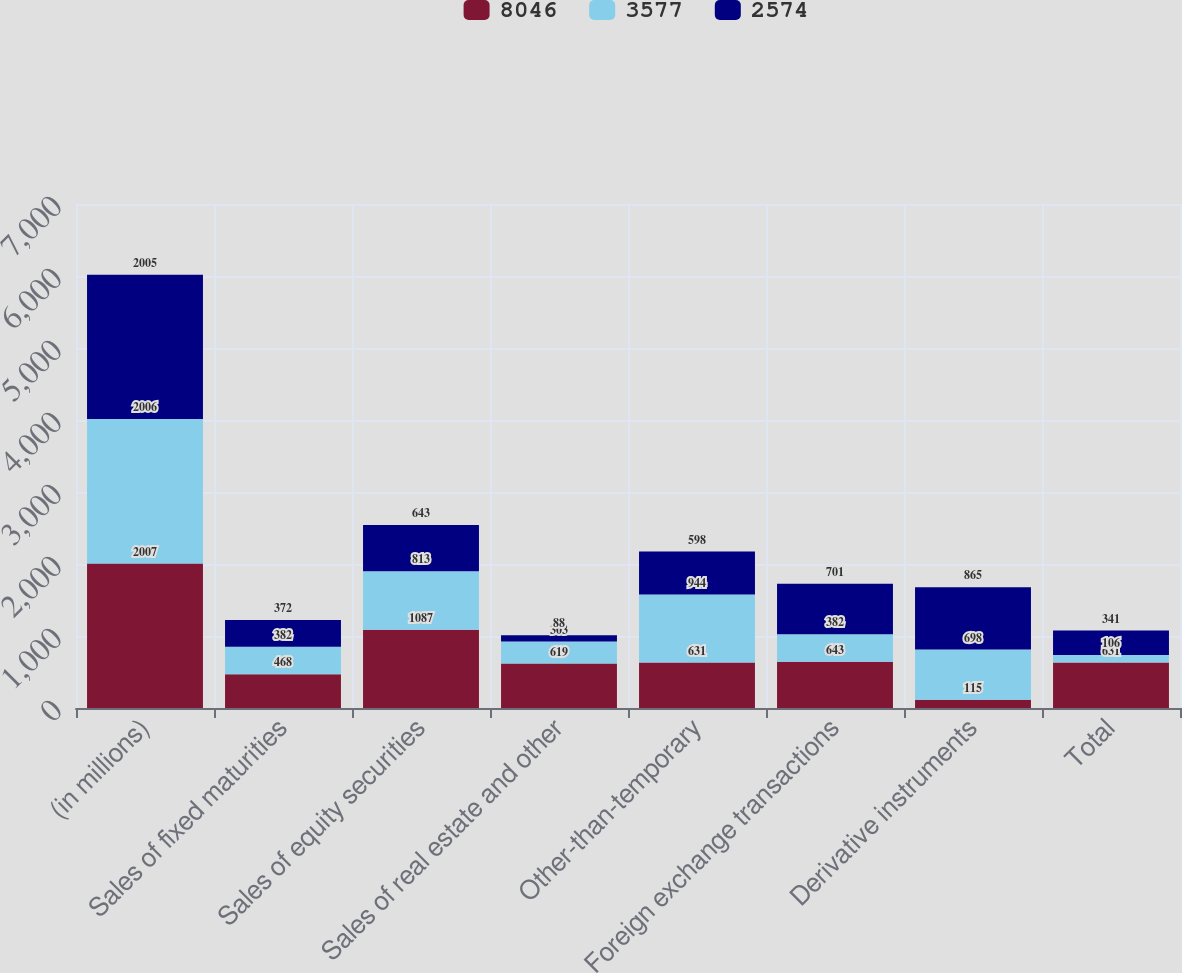Convert chart. <chart><loc_0><loc_0><loc_500><loc_500><stacked_bar_chart><ecel><fcel>(in millions)<fcel>Sales of fixed maturities<fcel>Sales of equity securities<fcel>Sales of real estate and other<fcel>Other-than-temporary<fcel>Foreign exchange transactions<fcel>Derivative instruments<fcel>Total<nl><fcel>8046<fcel>2007<fcel>468<fcel>1087<fcel>619<fcel>631<fcel>643<fcel>115<fcel>631<nl><fcel>3577<fcel>2006<fcel>382<fcel>813<fcel>303<fcel>944<fcel>382<fcel>698<fcel>106<nl><fcel>2574<fcel>2005<fcel>372<fcel>643<fcel>88<fcel>598<fcel>701<fcel>865<fcel>341<nl></chart> 